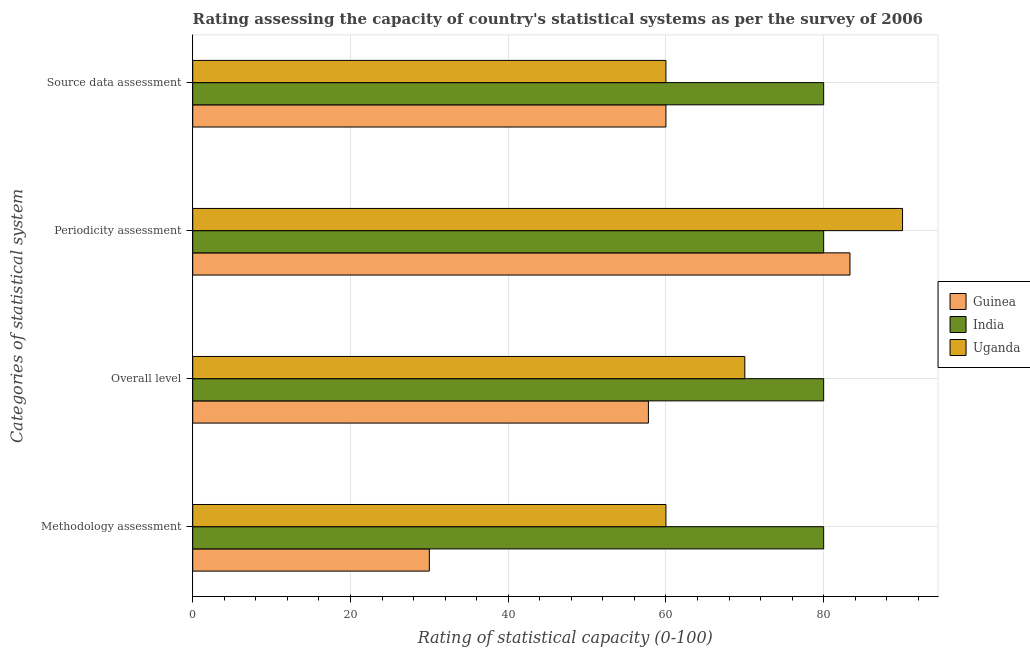How many groups of bars are there?
Offer a very short reply. 4. Are the number of bars on each tick of the Y-axis equal?
Keep it short and to the point. Yes. How many bars are there on the 3rd tick from the top?
Keep it short and to the point. 3. What is the label of the 4th group of bars from the top?
Your answer should be compact. Methodology assessment. In which country was the periodicity assessment rating maximum?
Offer a very short reply. Uganda. In which country was the source data assessment rating minimum?
Provide a succinct answer. Guinea. What is the total periodicity assessment rating in the graph?
Provide a succinct answer. 253.33. What is the difference between the overall level rating in Guinea and that in India?
Your answer should be very brief. -22.22. What is the difference between the methodology assessment rating in Uganda and the overall level rating in Guinea?
Offer a very short reply. 2.22. What is the average overall level rating per country?
Your answer should be very brief. 69.26. What is the difference between the overall level rating and source data assessment rating in India?
Ensure brevity in your answer.  0. What is the ratio of the source data assessment rating in Uganda to that in Guinea?
Your response must be concise. 1. Is the difference between the overall level rating in Guinea and India greater than the difference between the source data assessment rating in Guinea and India?
Your response must be concise. No. What is the difference between the highest and the lowest methodology assessment rating?
Provide a succinct answer. 50. In how many countries, is the periodicity assessment rating greater than the average periodicity assessment rating taken over all countries?
Give a very brief answer. 1. Is it the case that in every country, the sum of the overall level rating and periodicity assessment rating is greater than the sum of source data assessment rating and methodology assessment rating?
Ensure brevity in your answer.  Yes. What does the 1st bar from the top in Periodicity assessment represents?
Your answer should be compact. Uganda. What does the 2nd bar from the bottom in Overall level represents?
Offer a terse response. India. Is it the case that in every country, the sum of the methodology assessment rating and overall level rating is greater than the periodicity assessment rating?
Provide a succinct answer. Yes. How many bars are there?
Your answer should be compact. 12. Are the values on the major ticks of X-axis written in scientific E-notation?
Your answer should be very brief. No. Does the graph contain any zero values?
Ensure brevity in your answer.  No. Where does the legend appear in the graph?
Your answer should be very brief. Center right. How are the legend labels stacked?
Ensure brevity in your answer.  Vertical. What is the title of the graph?
Your answer should be compact. Rating assessing the capacity of country's statistical systems as per the survey of 2006 . What is the label or title of the X-axis?
Your response must be concise. Rating of statistical capacity (0-100). What is the label or title of the Y-axis?
Make the answer very short. Categories of statistical system. What is the Rating of statistical capacity (0-100) in Guinea in Methodology assessment?
Make the answer very short. 30. What is the Rating of statistical capacity (0-100) of Uganda in Methodology assessment?
Your response must be concise. 60. What is the Rating of statistical capacity (0-100) of Guinea in Overall level?
Give a very brief answer. 57.78. What is the Rating of statistical capacity (0-100) in India in Overall level?
Provide a short and direct response. 80. What is the Rating of statistical capacity (0-100) of Guinea in Periodicity assessment?
Provide a short and direct response. 83.33. What is the Rating of statistical capacity (0-100) of India in Periodicity assessment?
Offer a very short reply. 80. What is the Rating of statistical capacity (0-100) of India in Source data assessment?
Your response must be concise. 80. Across all Categories of statistical system, what is the maximum Rating of statistical capacity (0-100) in Guinea?
Make the answer very short. 83.33. Across all Categories of statistical system, what is the maximum Rating of statistical capacity (0-100) in India?
Keep it short and to the point. 80. Across all Categories of statistical system, what is the maximum Rating of statistical capacity (0-100) of Uganda?
Offer a terse response. 90. What is the total Rating of statistical capacity (0-100) in Guinea in the graph?
Your answer should be compact. 231.11. What is the total Rating of statistical capacity (0-100) in India in the graph?
Your answer should be compact. 320. What is the total Rating of statistical capacity (0-100) in Uganda in the graph?
Offer a terse response. 280. What is the difference between the Rating of statistical capacity (0-100) in Guinea in Methodology assessment and that in Overall level?
Offer a very short reply. -27.78. What is the difference between the Rating of statistical capacity (0-100) in Guinea in Methodology assessment and that in Periodicity assessment?
Give a very brief answer. -53.33. What is the difference between the Rating of statistical capacity (0-100) in Guinea in Methodology assessment and that in Source data assessment?
Your answer should be very brief. -30. What is the difference between the Rating of statistical capacity (0-100) of Guinea in Overall level and that in Periodicity assessment?
Your answer should be very brief. -25.56. What is the difference between the Rating of statistical capacity (0-100) in Uganda in Overall level and that in Periodicity assessment?
Offer a terse response. -20. What is the difference between the Rating of statistical capacity (0-100) in Guinea in Overall level and that in Source data assessment?
Your response must be concise. -2.22. What is the difference between the Rating of statistical capacity (0-100) of Uganda in Overall level and that in Source data assessment?
Your answer should be very brief. 10. What is the difference between the Rating of statistical capacity (0-100) in Guinea in Periodicity assessment and that in Source data assessment?
Your answer should be compact. 23.33. What is the difference between the Rating of statistical capacity (0-100) of India in Periodicity assessment and that in Source data assessment?
Provide a succinct answer. 0. What is the difference between the Rating of statistical capacity (0-100) in Guinea in Methodology assessment and the Rating of statistical capacity (0-100) in India in Overall level?
Your response must be concise. -50. What is the difference between the Rating of statistical capacity (0-100) in India in Methodology assessment and the Rating of statistical capacity (0-100) in Uganda in Overall level?
Provide a succinct answer. 10. What is the difference between the Rating of statistical capacity (0-100) in Guinea in Methodology assessment and the Rating of statistical capacity (0-100) in India in Periodicity assessment?
Your answer should be very brief. -50. What is the difference between the Rating of statistical capacity (0-100) of Guinea in Methodology assessment and the Rating of statistical capacity (0-100) of Uganda in Periodicity assessment?
Give a very brief answer. -60. What is the difference between the Rating of statistical capacity (0-100) in Guinea in Methodology assessment and the Rating of statistical capacity (0-100) in Uganda in Source data assessment?
Keep it short and to the point. -30. What is the difference between the Rating of statistical capacity (0-100) of India in Methodology assessment and the Rating of statistical capacity (0-100) of Uganda in Source data assessment?
Offer a very short reply. 20. What is the difference between the Rating of statistical capacity (0-100) of Guinea in Overall level and the Rating of statistical capacity (0-100) of India in Periodicity assessment?
Give a very brief answer. -22.22. What is the difference between the Rating of statistical capacity (0-100) of Guinea in Overall level and the Rating of statistical capacity (0-100) of Uganda in Periodicity assessment?
Ensure brevity in your answer.  -32.22. What is the difference between the Rating of statistical capacity (0-100) in India in Overall level and the Rating of statistical capacity (0-100) in Uganda in Periodicity assessment?
Provide a succinct answer. -10. What is the difference between the Rating of statistical capacity (0-100) of Guinea in Overall level and the Rating of statistical capacity (0-100) of India in Source data assessment?
Offer a terse response. -22.22. What is the difference between the Rating of statistical capacity (0-100) of Guinea in Overall level and the Rating of statistical capacity (0-100) of Uganda in Source data assessment?
Your answer should be very brief. -2.22. What is the difference between the Rating of statistical capacity (0-100) of Guinea in Periodicity assessment and the Rating of statistical capacity (0-100) of India in Source data assessment?
Offer a terse response. 3.33. What is the difference between the Rating of statistical capacity (0-100) in Guinea in Periodicity assessment and the Rating of statistical capacity (0-100) in Uganda in Source data assessment?
Provide a succinct answer. 23.33. What is the difference between the Rating of statistical capacity (0-100) in India in Periodicity assessment and the Rating of statistical capacity (0-100) in Uganda in Source data assessment?
Offer a terse response. 20. What is the average Rating of statistical capacity (0-100) of Guinea per Categories of statistical system?
Keep it short and to the point. 57.78. What is the difference between the Rating of statistical capacity (0-100) in Guinea and Rating of statistical capacity (0-100) in Uganda in Methodology assessment?
Offer a very short reply. -30. What is the difference between the Rating of statistical capacity (0-100) of India and Rating of statistical capacity (0-100) of Uganda in Methodology assessment?
Make the answer very short. 20. What is the difference between the Rating of statistical capacity (0-100) in Guinea and Rating of statistical capacity (0-100) in India in Overall level?
Offer a very short reply. -22.22. What is the difference between the Rating of statistical capacity (0-100) of Guinea and Rating of statistical capacity (0-100) of Uganda in Overall level?
Offer a terse response. -12.22. What is the difference between the Rating of statistical capacity (0-100) in Guinea and Rating of statistical capacity (0-100) in Uganda in Periodicity assessment?
Ensure brevity in your answer.  -6.67. What is the difference between the Rating of statistical capacity (0-100) in India and Rating of statistical capacity (0-100) in Uganda in Periodicity assessment?
Keep it short and to the point. -10. What is the ratio of the Rating of statistical capacity (0-100) in Guinea in Methodology assessment to that in Overall level?
Your answer should be compact. 0.52. What is the ratio of the Rating of statistical capacity (0-100) of Guinea in Methodology assessment to that in Periodicity assessment?
Your answer should be compact. 0.36. What is the ratio of the Rating of statistical capacity (0-100) in Uganda in Methodology assessment to that in Periodicity assessment?
Offer a terse response. 0.67. What is the ratio of the Rating of statistical capacity (0-100) in India in Methodology assessment to that in Source data assessment?
Ensure brevity in your answer.  1. What is the ratio of the Rating of statistical capacity (0-100) of Guinea in Overall level to that in Periodicity assessment?
Ensure brevity in your answer.  0.69. What is the ratio of the Rating of statistical capacity (0-100) of India in Overall level to that in Periodicity assessment?
Give a very brief answer. 1. What is the ratio of the Rating of statistical capacity (0-100) of Guinea in Overall level to that in Source data assessment?
Your answer should be compact. 0.96. What is the ratio of the Rating of statistical capacity (0-100) in Uganda in Overall level to that in Source data assessment?
Your response must be concise. 1.17. What is the ratio of the Rating of statistical capacity (0-100) in Guinea in Periodicity assessment to that in Source data assessment?
Give a very brief answer. 1.39. What is the ratio of the Rating of statistical capacity (0-100) in India in Periodicity assessment to that in Source data assessment?
Give a very brief answer. 1. What is the ratio of the Rating of statistical capacity (0-100) of Uganda in Periodicity assessment to that in Source data assessment?
Your answer should be very brief. 1.5. What is the difference between the highest and the second highest Rating of statistical capacity (0-100) of Guinea?
Provide a succinct answer. 23.33. What is the difference between the highest and the second highest Rating of statistical capacity (0-100) of India?
Offer a very short reply. 0. What is the difference between the highest and the second highest Rating of statistical capacity (0-100) in Uganda?
Provide a succinct answer. 20. What is the difference between the highest and the lowest Rating of statistical capacity (0-100) of Guinea?
Provide a succinct answer. 53.33. What is the difference between the highest and the lowest Rating of statistical capacity (0-100) in Uganda?
Offer a terse response. 30. 